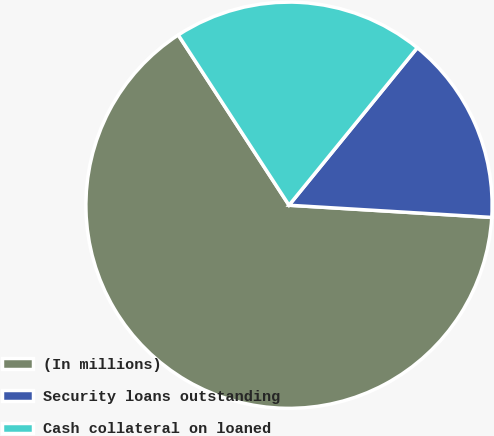Convert chart to OTSL. <chart><loc_0><loc_0><loc_500><loc_500><pie_chart><fcel>(In millions)<fcel>Security loans outstanding<fcel>Cash collateral on loaned<nl><fcel>64.87%<fcel>15.08%<fcel>20.06%<nl></chart> 